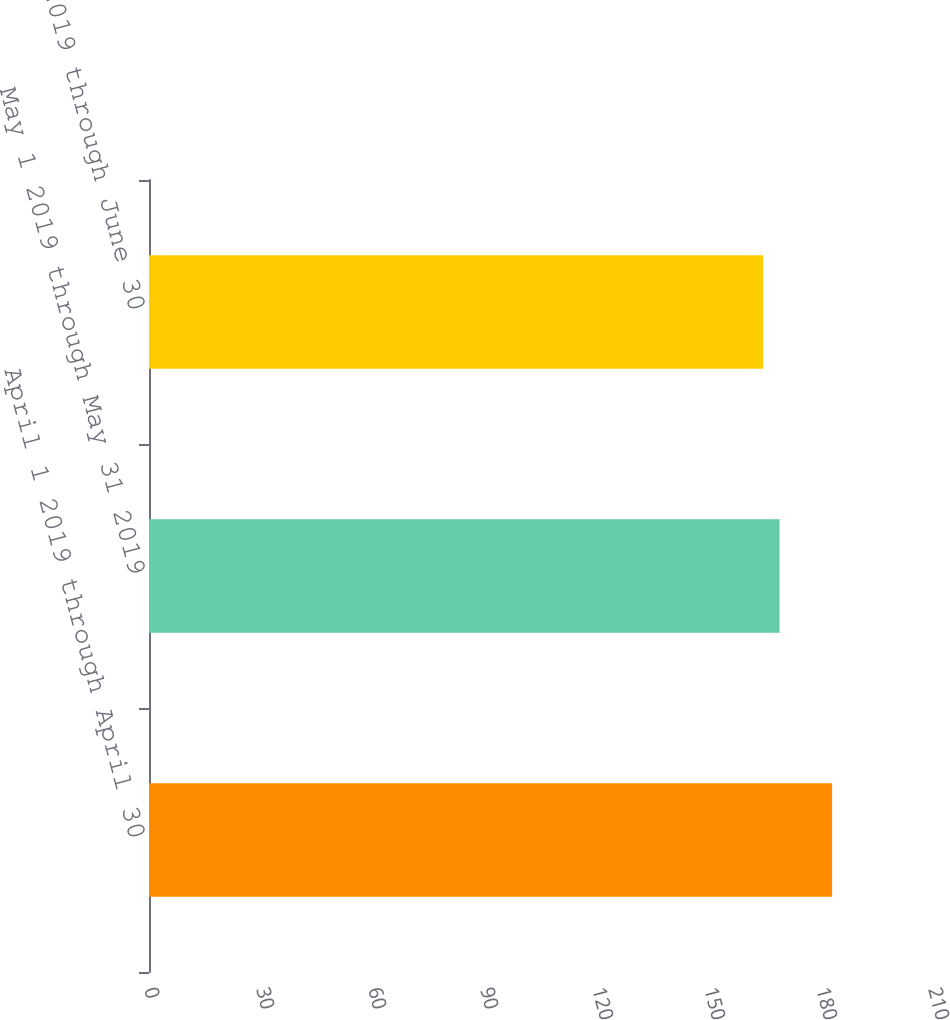Convert chart to OTSL. <chart><loc_0><loc_0><loc_500><loc_500><bar_chart><fcel>April 1 2019 through April 30<fcel>May 1 2019 through May 31 2019<fcel>June 1 2019 through June 30<nl><fcel>182.97<fcel>168.89<fcel>164.5<nl></chart> 